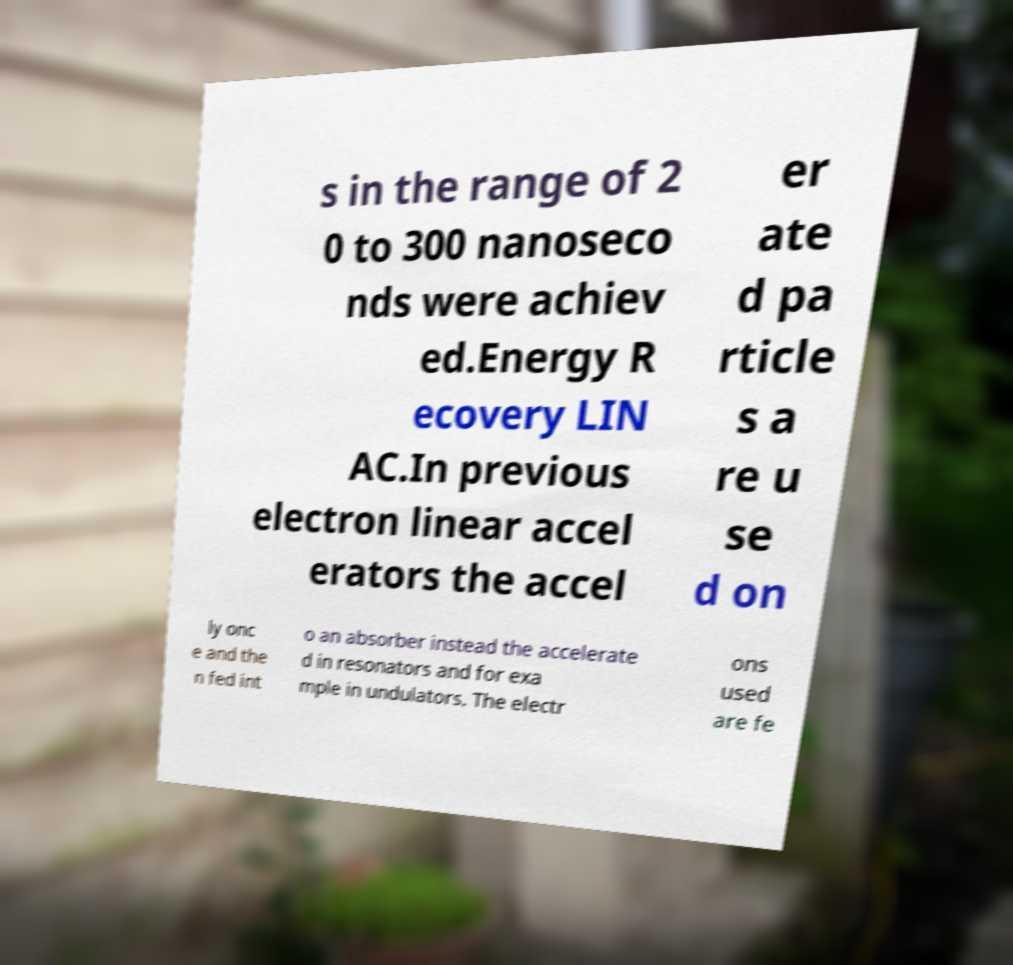Please identify and transcribe the text found in this image. s in the range of 2 0 to 300 nanoseco nds were achiev ed.Energy R ecovery LIN AC.In previous electron linear accel erators the accel er ate d pa rticle s a re u se d on ly onc e and the n fed int o an absorber instead the accelerate d in resonators and for exa mple in undulators. The electr ons used are fe 